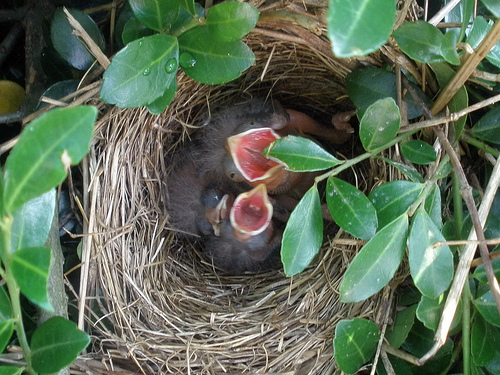How many birds are there? 3 